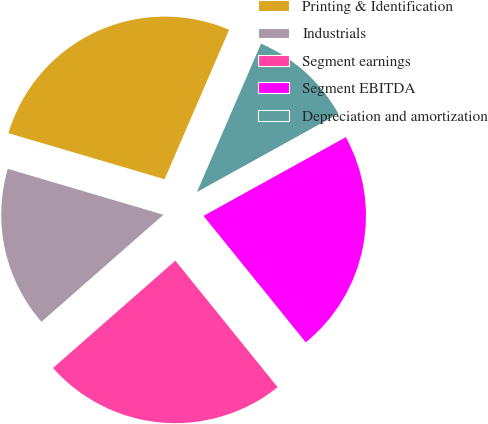<chart> <loc_0><loc_0><loc_500><loc_500><pie_chart><fcel>Printing & Identification<fcel>Industrials<fcel>Segment earnings<fcel>Segment EBITDA<fcel>Depreciation and amortization<nl><fcel>26.92%<fcel>16.03%<fcel>24.36%<fcel>22.22%<fcel>10.47%<nl></chart> 